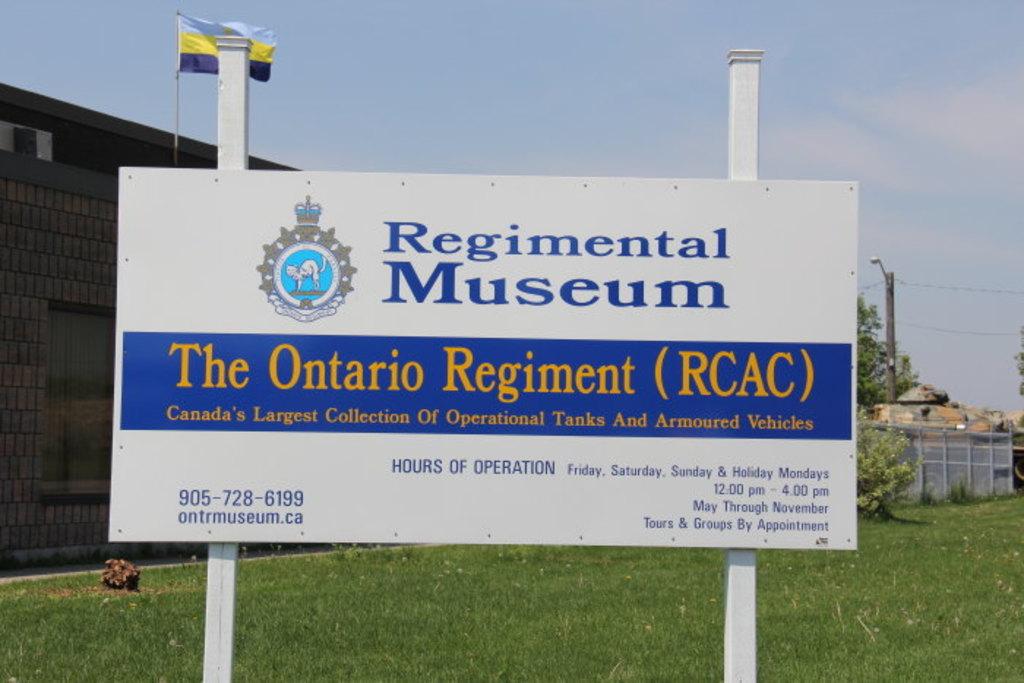What is the phone number for the establishment?
Make the answer very short. 905-728-6199. What does the first two words at the top say?
Your answer should be compact. Regimental museum. 